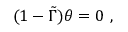Convert formula to latex. <formula><loc_0><loc_0><loc_500><loc_500>( 1 - \tilde { \Gamma } ) \theta = 0 \ ,</formula> 